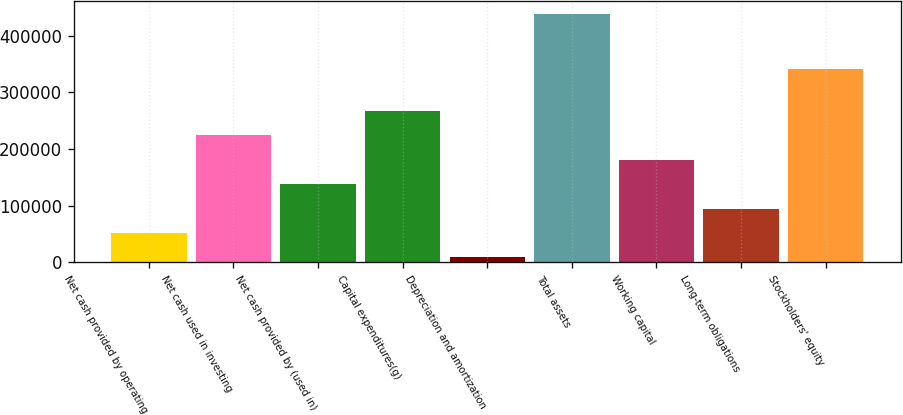<chart> <loc_0><loc_0><loc_500><loc_500><bar_chart><fcel>Net cash provided by operating<fcel>Net cash used in investing<fcel>Net cash provided by (used in)<fcel>Capital expenditures(g)<fcel>Depreciation and amortization<fcel>Total assets<fcel>Working capital<fcel>Long-term obligations<fcel>Stockholders' equity<nl><fcel>51659.2<fcel>224000<fcel>137830<fcel>267085<fcel>8574<fcel>439426<fcel>180915<fcel>94744.4<fcel>341220<nl></chart> 